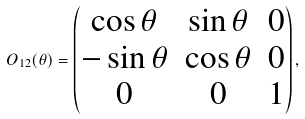<formula> <loc_0><loc_0><loc_500><loc_500>O _ { 1 2 } ( \theta ) = \begin{pmatrix} \cos \theta & \sin \theta & 0 \\ - \sin \theta & \cos \theta & 0 \\ 0 & 0 & 1 \end{pmatrix} ,</formula> 